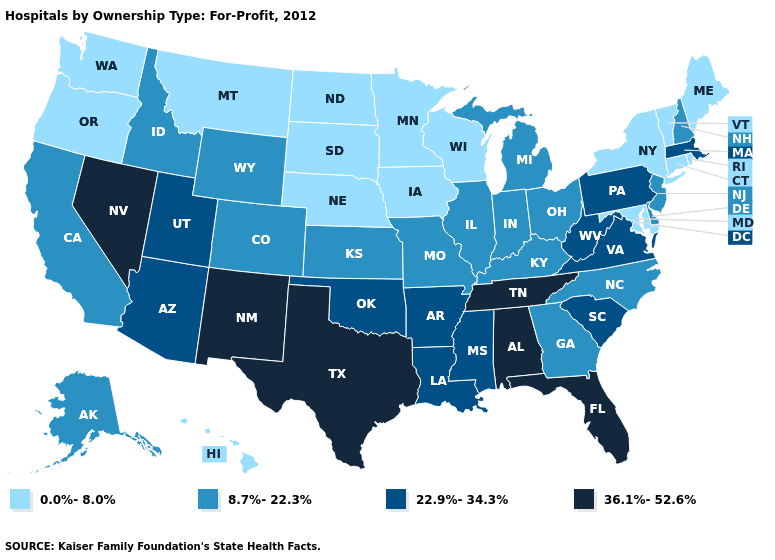Does Montana have the highest value in the USA?
Keep it brief. No. Among the states that border Arkansas , which have the lowest value?
Short answer required. Missouri. Among the states that border Montana , which have the lowest value?
Keep it brief. North Dakota, South Dakota. Does Nevada have a higher value than Tennessee?
Give a very brief answer. No. What is the value of California?
Keep it brief. 8.7%-22.3%. What is the value of Rhode Island?
Short answer required. 0.0%-8.0%. Name the states that have a value in the range 22.9%-34.3%?
Give a very brief answer. Arizona, Arkansas, Louisiana, Massachusetts, Mississippi, Oklahoma, Pennsylvania, South Carolina, Utah, Virginia, West Virginia. What is the value of Connecticut?
Concise answer only. 0.0%-8.0%. Name the states that have a value in the range 0.0%-8.0%?
Answer briefly. Connecticut, Hawaii, Iowa, Maine, Maryland, Minnesota, Montana, Nebraska, New York, North Dakota, Oregon, Rhode Island, South Dakota, Vermont, Washington, Wisconsin. Name the states that have a value in the range 0.0%-8.0%?
Give a very brief answer. Connecticut, Hawaii, Iowa, Maine, Maryland, Minnesota, Montana, Nebraska, New York, North Dakota, Oregon, Rhode Island, South Dakota, Vermont, Washington, Wisconsin. Name the states that have a value in the range 8.7%-22.3%?
Quick response, please. Alaska, California, Colorado, Delaware, Georgia, Idaho, Illinois, Indiana, Kansas, Kentucky, Michigan, Missouri, New Hampshire, New Jersey, North Carolina, Ohio, Wyoming. Does New York have the highest value in the USA?
Short answer required. No. Name the states that have a value in the range 22.9%-34.3%?
Answer briefly. Arizona, Arkansas, Louisiana, Massachusetts, Mississippi, Oklahoma, Pennsylvania, South Carolina, Utah, Virginia, West Virginia. How many symbols are there in the legend?
Give a very brief answer. 4. Among the states that border West Virginia , does Pennsylvania have the highest value?
Quick response, please. Yes. 